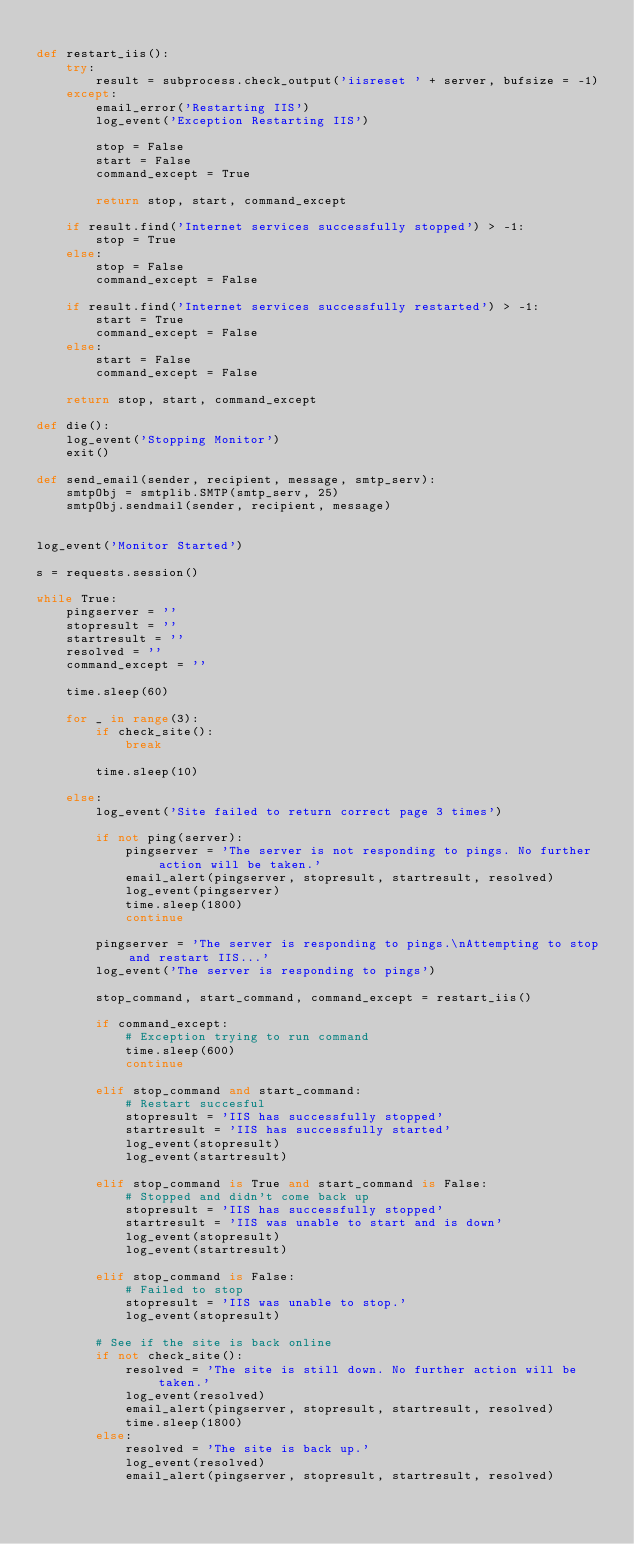<code> <loc_0><loc_0><loc_500><loc_500><_Python_>
def restart_iis():
    try:
        result = subprocess.check_output('iisreset ' + server, bufsize = -1)
    except:
        email_error('Restarting IIS')
        log_event('Exception Restarting IIS')

        stop = False
        start = False
        command_except = True

        return stop, start, command_except        

    if result.find('Internet services successfully stopped') > -1:
        stop = True
    else:
        stop = False
        command_except = False 

    if result.find('Internet services successfully restarted') > -1:
        start = True
        command_except = False
    else:
        start = False 
        command_except = False

    return stop, start, command_except

def die():
    log_event('Stopping Monitor')
    exit()

def send_email(sender, recipient, message, smtp_serv):
    smtpObj = smtplib.SMTP(smtp_serv, 25)
    smtpObj.sendmail(sender, recipient, message)


log_event('Monitor Started')

s = requests.session()

while True:
    pingserver = ''
    stopresult = ''
    startresult = ''
    resolved = ''
    command_except = ''

    time.sleep(60)
    
    for _ in range(3):
        if check_site():
            break
            
        time.sleep(10)

    else:
        log_event('Site failed to return correct page 3 times')

        if not ping(server):
            pingserver = 'The server is not responding to pings. No further action will be taken.'
            email_alert(pingserver, stopresult, startresult, resolved)
            log_event(pingserver)
            time.sleep(1800)
            continue

        pingserver = 'The server is responding to pings.\nAttempting to stop and restart IIS...'
        log_event('The server is responding to pings')
        
        stop_command, start_command, command_except = restart_iis()

        if command_except:
            # Exception trying to run command
            time.sleep(600)
            continue

        elif stop_command and start_command:
            # Restart succesful
            stopresult = 'IIS has successfully stopped'
            startresult = 'IIS has successfully started'
            log_event(stopresult)
            log_event(startresult)

        elif stop_command is True and start_command is False:
            # Stopped and didn't come back up
            stopresult = 'IIS has successfully stopped'
            startresult = 'IIS was unable to start and is down'
            log_event(stopresult)
            log_event(startresult)

        elif stop_command is False:
            # Failed to stop
            stopresult = 'IIS was unable to stop.'
            log_event(stopresult)

        # See if the site is back online
        if not check_site():
            resolved = 'The site is still down. No further action will be taken.'
            log_event(resolved)
            email_alert(pingserver, stopresult, startresult, resolved)
            time.sleep(1800)
        else:
            resolved = 'The site is back up.'
            log_event(resolved)
            email_alert(pingserver, stopresult, startresult, resolved)
</code> 